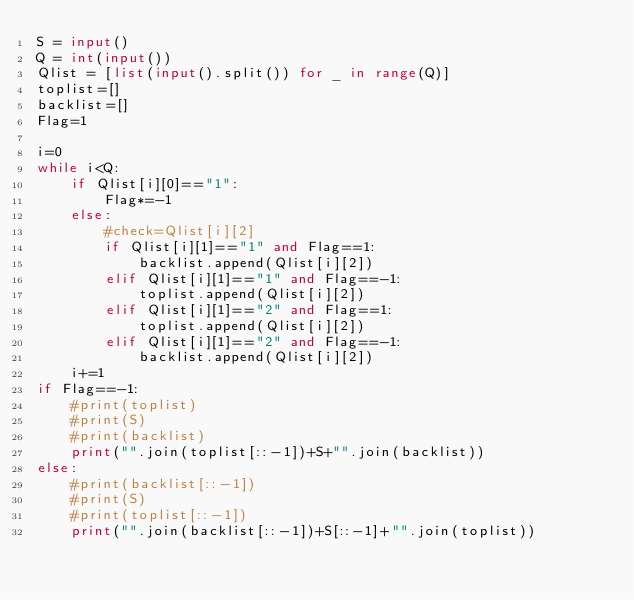<code> <loc_0><loc_0><loc_500><loc_500><_Python_>S = input()
Q = int(input())
Qlist = [list(input().split()) for _ in range(Q)]
toplist=[]
backlist=[]
Flag=1

i=0
while i<Q:
    if Qlist[i][0]=="1":
        Flag*=-1
    else:
        #check=Qlist[i][2]
        if Qlist[i][1]=="1" and Flag==1:
            backlist.append(Qlist[i][2])
        elif Qlist[i][1]=="1" and Flag==-1:
            toplist.append(Qlist[i][2])
        elif Qlist[i][1]=="2" and Flag==1:
            toplist.append(Qlist[i][2])
        elif Qlist[i][1]=="2" and Flag==-1:
            backlist.append(Qlist[i][2])
    i+=1
if Flag==-1:
    #print(toplist)
    #print(S)
    #print(backlist)
    print("".join(toplist[::-1])+S+"".join(backlist))
else:
    #print(backlist[::-1])
    #print(S)
    #print(toplist[::-1])
    print("".join(backlist[::-1])+S[::-1]+"".join(toplist))</code> 